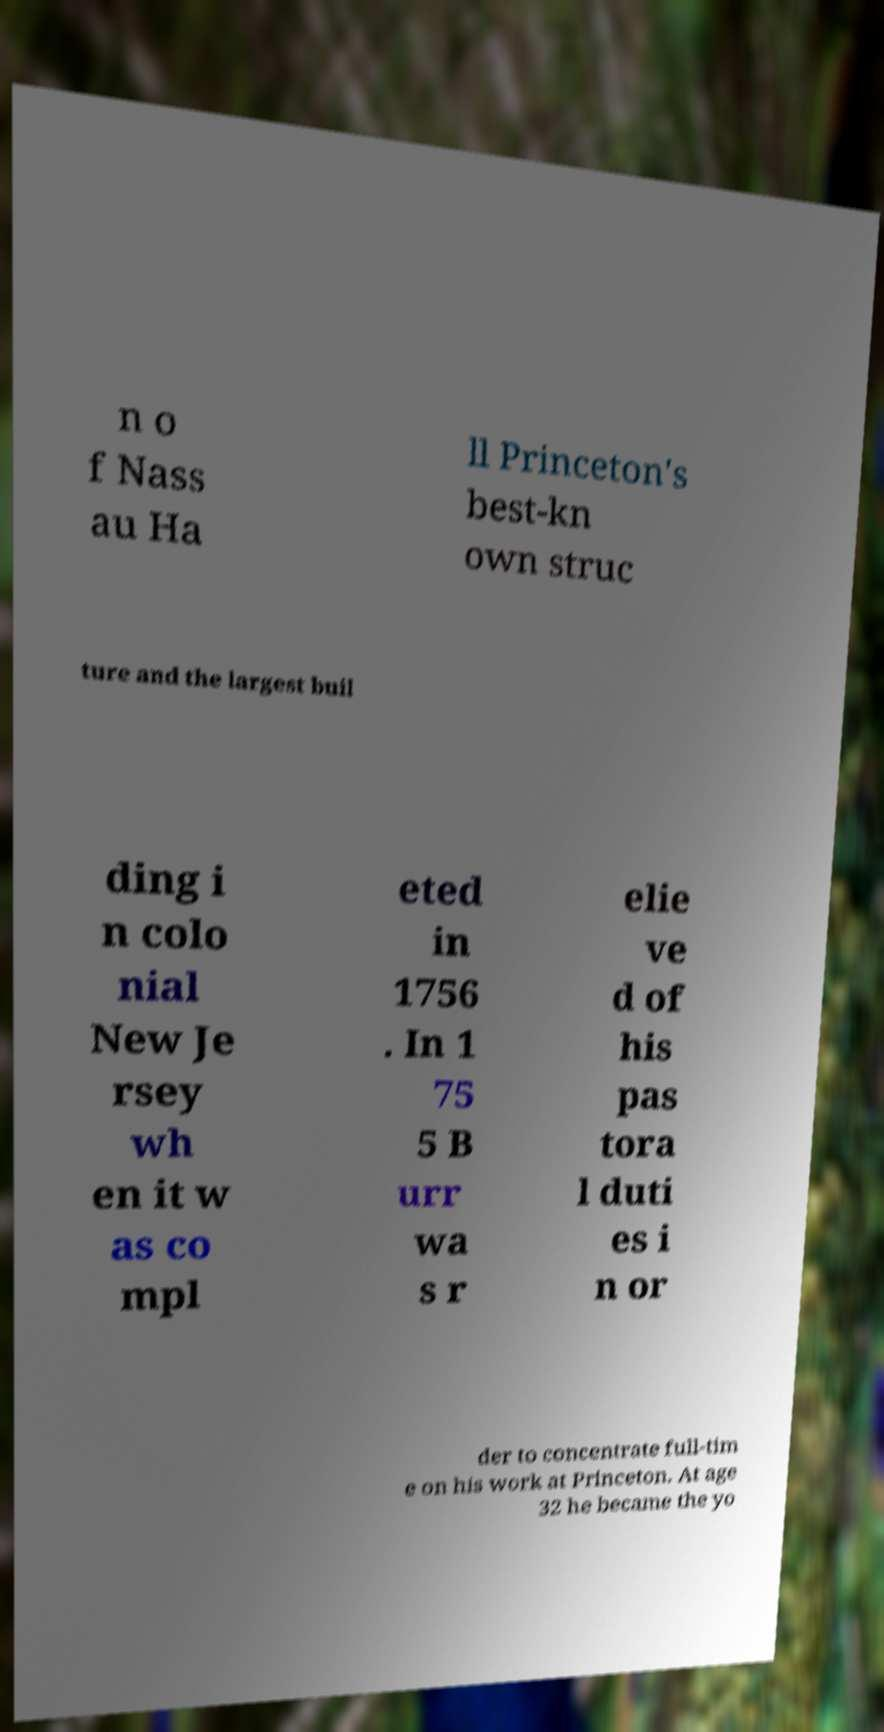I need the written content from this picture converted into text. Can you do that? n o f Nass au Ha ll Princeton's best-kn own struc ture and the largest buil ding i n colo nial New Je rsey wh en it w as co mpl eted in 1756 . In 1 75 5 B urr wa s r elie ve d of his pas tora l duti es i n or der to concentrate full-tim e on his work at Princeton. At age 32 he became the yo 